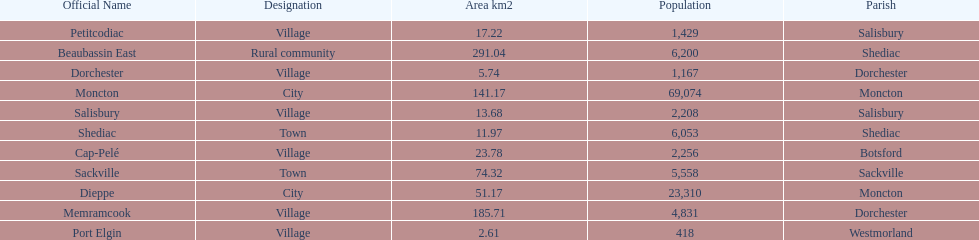The only rural community on the list Beaubassin East. 